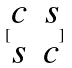<formula> <loc_0><loc_0><loc_500><loc_500>[ \begin{matrix} c & s \\ s & c \end{matrix} ]</formula> 